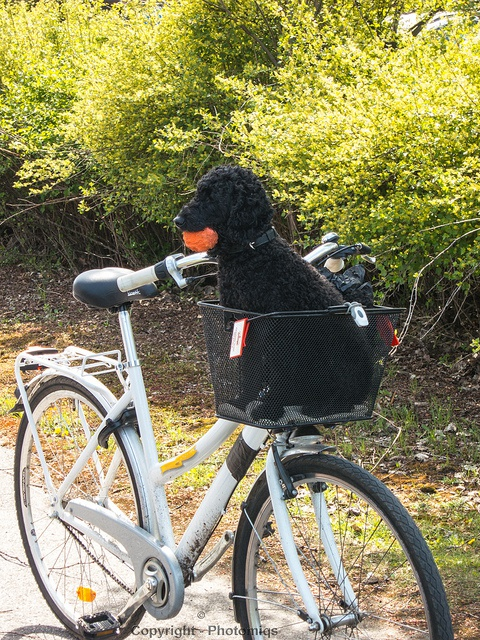Describe the objects in this image and their specific colors. I can see bicycle in olive, lightgray, gray, darkgray, and black tones, dog in olive, black, gray, and purple tones, and sports ball in olive, red, salmon, and brown tones in this image. 